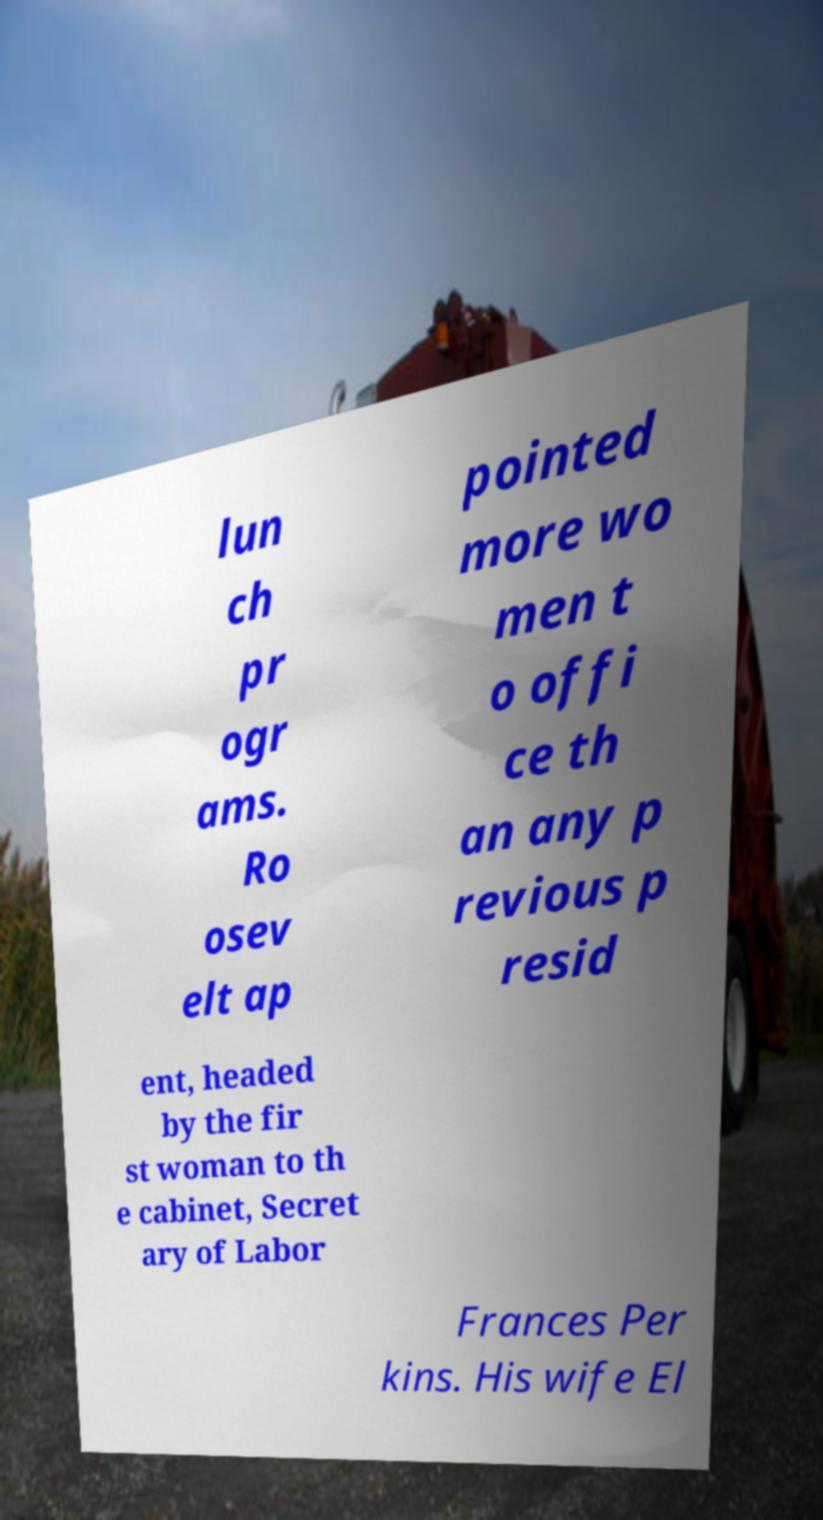What messages or text are displayed in this image? I need them in a readable, typed format. lun ch pr ogr ams. Ro osev elt ap pointed more wo men t o offi ce th an any p revious p resid ent, headed by the fir st woman to th e cabinet, Secret ary of Labor Frances Per kins. His wife El 